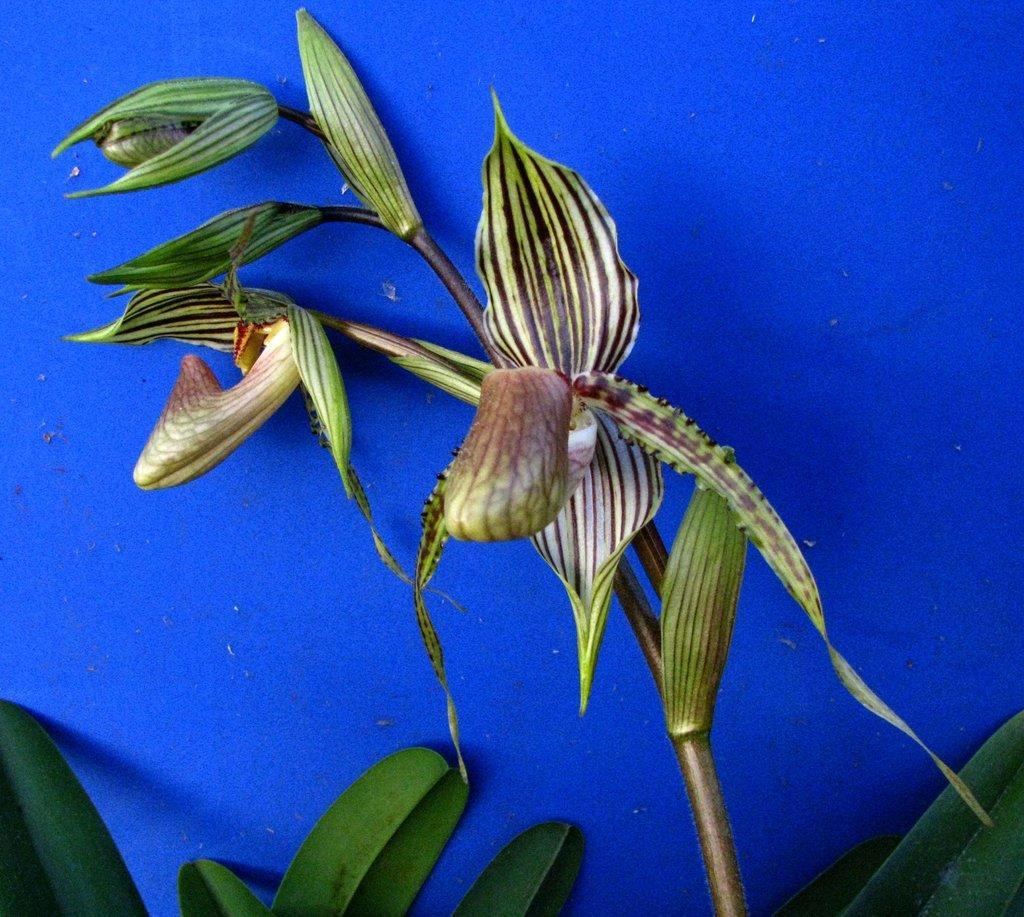Can you describe this image briefly? In this image we can see the plants with blue background. 